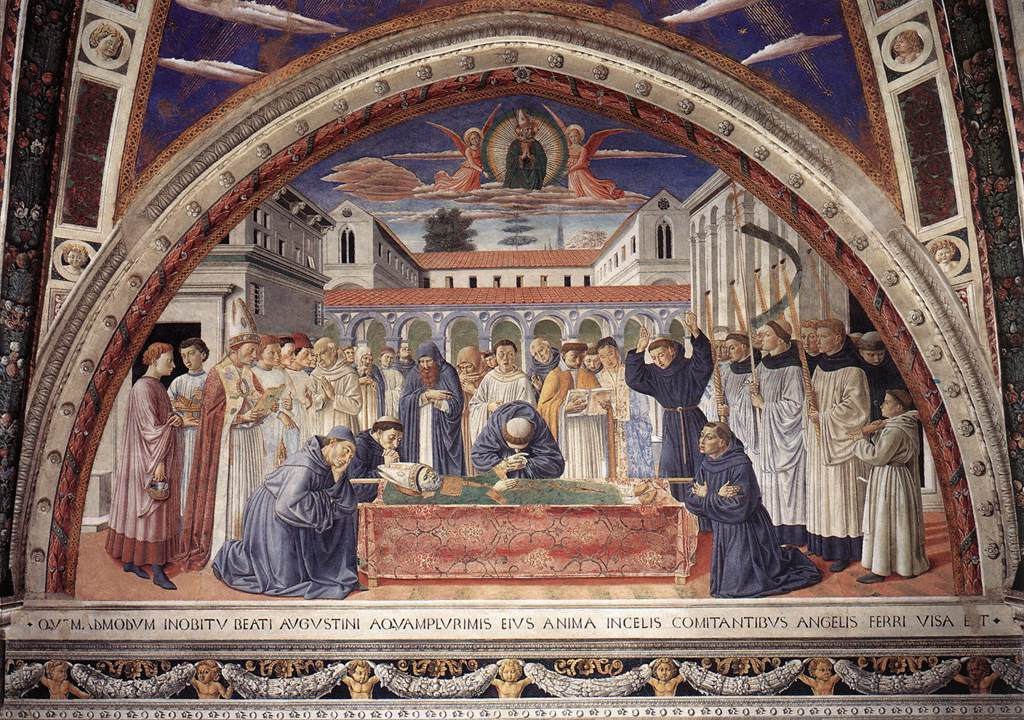Can you elaborate on the elements of the picture provided? The image displays a captivating fresco painting in the Gothic style, a genre of Medieval European art. This scene reveals a courtyard gathering around a central figure lying on a bed, likely depicting a saintly or royal figure's final moments. The attendees are dressed in distinctively medieval attire, with predominant colors of red, blue, and gold, enhancing the richness of the composition.

The backdrop features detailed architectural elements, including a grand building with a dome and a smaller, pointed-roof structure, indicating perhaps a religious or royal location. An ornate arch with intricate gold and red patterns frames the entire scene, accentuating the fresco's depth and elegance. Additionally, the phrase "QVI.M" appears in the painting, suggesting some specific, though unclear, significance.

Overall, this painting vividly represents a significant religious or historical event, distinguished by Gothic stylistic elements such as detailed figures, rich colors, and elaborate architecture, all contributing to the narrative and visual impact. 